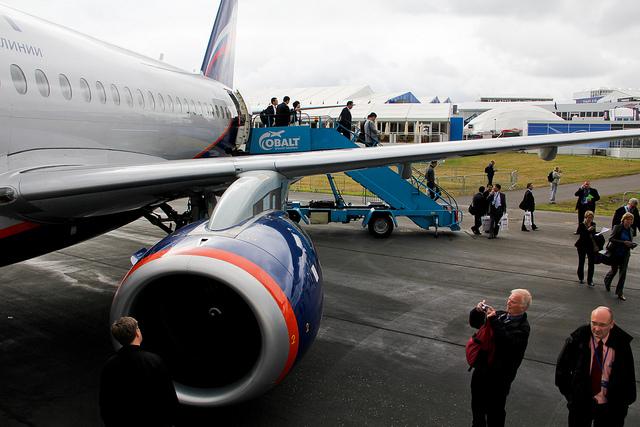Is someone posing for a picture?
Give a very brief answer. No. What is the dominant color of clothing worn by the people in this photo?
Quick response, please. Black. What company name is on the stairway?
Keep it brief. Cobalt. 